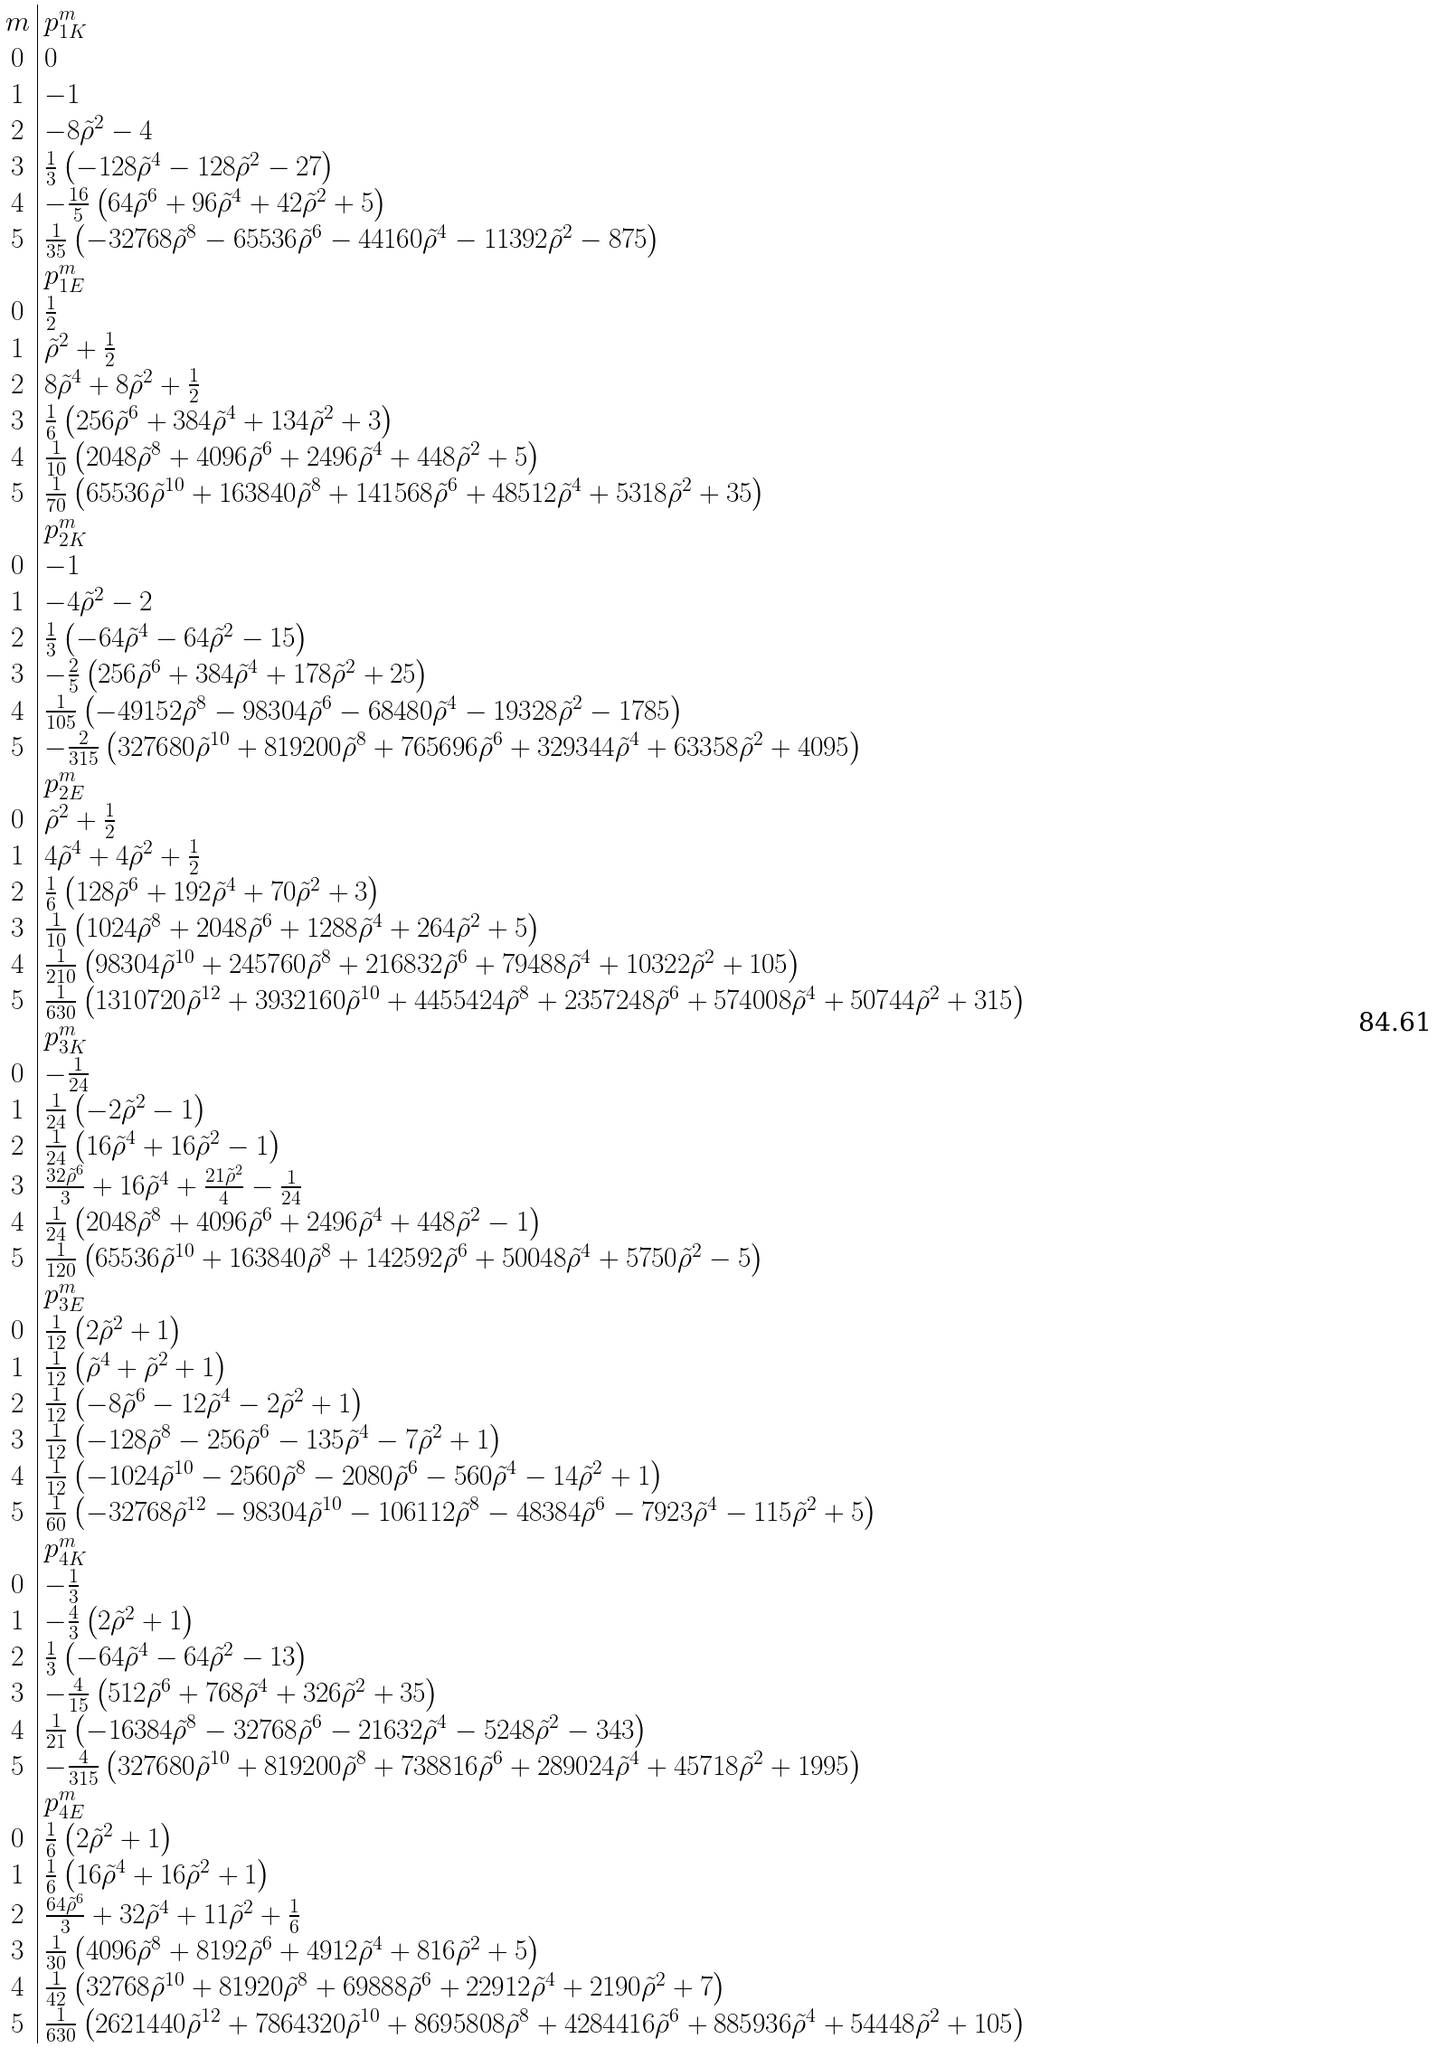<formula> <loc_0><loc_0><loc_500><loc_500>\begin{array} { c | l } m & p _ { 1 K } ^ { m } \\ 0 & 0 \\ 1 & - 1 \\ 2 & - 8 \tilde { \rho } ^ { 2 } - 4 \\ 3 & \frac { 1 } { 3 } \left ( - 1 2 8 \tilde { \rho } ^ { 4 } - 1 2 8 \tilde { \rho } ^ { 2 } - 2 7 \right ) \\ 4 & - \frac { 1 6 } { 5 } \left ( 6 4 \tilde { \rho } ^ { 6 } + 9 6 \tilde { \rho } ^ { 4 } + 4 2 \tilde { \rho } ^ { 2 } + 5 \right ) \\ 5 & \frac { 1 } { 3 5 } \left ( - 3 2 7 6 8 \tilde { \rho } ^ { 8 } - 6 5 5 3 6 \tilde { \rho } ^ { 6 } - 4 4 1 6 0 \tilde { \rho } ^ { 4 } - 1 1 3 9 2 \tilde { \rho } ^ { 2 } - 8 7 5 \right ) \\ & p _ { 1 E } ^ { m } \\ 0 & \frac { 1 } { 2 } \\ 1 & \tilde { \rho } ^ { 2 } + \frac { 1 } { 2 } \\ 2 & 8 \tilde { \rho } ^ { 4 } + 8 \tilde { \rho } ^ { 2 } + \frac { 1 } { 2 } \\ 3 & \frac { 1 } { 6 } \left ( 2 5 6 \tilde { \rho } ^ { 6 } + 3 8 4 \tilde { \rho } ^ { 4 } + 1 3 4 \tilde { \rho } ^ { 2 } + 3 \right ) \\ 4 & \frac { 1 } { 1 0 } \left ( 2 0 4 8 \tilde { \rho } ^ { 8 } + 4 0 9 6 \tilde { \rho } ^ { 6 } + 2 4 9 6 \tilde { \rho } ^ { 4 } + 4 4 8 \tilde { \rho } ^ { 2 } + 5 \right ) \\ 5 & \frac { 1 } { 7 0 } \left ( 6 5 5 3 6 \tilde { \rho } ^ { 1 0 } + 1 6 3 8 4 0 \tilde { \rho } ^ { 8 } + 1 4 1 5 6 8 \tilde { \rho } ^ { 6 } + 4 8 5 1 2 \tilde { \rho } ^ { 4 } + 5 3 1 8 \tilde { \rho } ^ { 2 } + 3 5 \right ) \\ & p _ { 2 K } ^ { m } \\ 0 & - 1 \\ 1 & - 4 \tilde { \rho } ^ { 2 } - 2 \\ 2 & \frac { 1 } { 3 } \left ( - 6 4 \tilde { \rho } ^ { 4 } - 6 4 \tilde { \rho } ^ { 2 } - 1 5 \right ) \\ 3 & - \frac { 2 } { 5 } \left ( 2 5 6 \tilde { \rho } ^ { 6 } + 3 8 4 \tilde { \rho } ^ { 4 } + 1 7 8 \tilde { \rho } ^ { 2 } + 2 5 \right ) \\ 4 & \frac { 1 } { 1 0 5 } \left ( - 4 9 1 5 2 \tilde { \rho } ^ { 8 } - 9 8 3 0 4 \tilde { \rho } ^ { 6 } - 6 8 4 8 0 \tilde { \rho } ^ { 4 } - 1 9 3 2 8 \tilde { \rho } ^ { 2 } - 1 7 8 5 \right ) \\ 5 & - \frac { 2 } { 3 1 5 } \left ( 3 2 7 6 8 0 \tilde { \rho } ^ { 1 0 } + 8 1 9 2 0 0 \tilde { \rho } ^ { 8 } + 7 6 5 6 9 6 \tilde { \rho } ^ { 6 } + 3 2 9 3 4 4 \tilde { \rho } ^ { 4 } + 6 3 3 5 8 \tilde { \rho } ^ { 2 } + 4 0 9 5 \right ) \\ & p _ { 2 E } ^ { m } \\ 0 & \tilde { \rho } ^ { 2 } + \frac { 1 } { 2 } \\ 1 & 4 \tilde { \rho } ^ { 4 } + 4 \tilde { \rho } ^ { 2 } + \frac { 1 } { 2 } \\ 2 & \frac { 1 } { 6 } \left ( 1 2 8 \tilde { \rho } ^ { 6 } + 1 9 2 \tilde { \rho } ^ { 4 } + 7 0 \tilde { \rho } ^ { 2 } + 3 \right ) \\ 3 & \frac { 1 } { 1 0 } \left ( 1 0 2 4 \tilde { \rho } ^ { 8 } + 2 0 4 8 \tilde { \rho } ^ { 6 } + 1 2 8 8 \tilde { \rho } ^ { 4 } + 2 6 4 \tilde { \rho } ^ { 2 } + 5 \right ) \\ 4 & \frac { 1 } { 2 1 0 } \left ( 9 8 3 0 4 \tilde { \rho } ^ { 1 0 } + 2 4 5 7 6 0 \tilde { \rho } ^ { 8 } + 2 1 6 8 3 2 \tilde { \rho } ^ { 6 } + 7 9 4 8 8 \tilde { \rho } ^ { 4 } + 1 0 3 2 2 \tilde { \rho } ^ { 2 } + 1 0 5 \right ) \\ 5 & \frac { 1 } { 6 3 0 } \left ( 1 3 1 0 7 2 0 \tilde { \rho } ^ { 1 2 } + 3 9 3 2 1 6 0 \tilde { \rho } ^ { 1 0 } + 4 4 5 5 4 2 4 \tilde { \rho } ^ { 8 } + 2 3 5 7 2 4 8 \tilde { \rho } ^ { 6 } + 5 7 4 0 0 8 \tilde { \rho } ^ { 4 } + 5 0 7 4 4 \tilde { \rho } ^ { 2 } + 3 1 5 \right ) \\ & p _ { 3 K } ^ { m } \\ 0 & - \frac { 1 } { 2 4 } \\ 1 & \frac { 1 } { 2 4 } \left ( - 2 \tilde { \rho } ^ { 2 } - 1 \right ) \\ 2 & \frac { 1 } { 2 4 } \left ( 1 6 \tilde { \rho } ^ { 4 } + 1 6 \tilde { \rho } ^ { 2 } - 1 \right ) \\ 3 & \frac { 3 2 \tilde { \rho } ^ { 6 } } { 3 } + 1 6 \tilde { \rho } ^ { 4 } + \frac { 2 1 \tilde { \rho } ^ { 2 } } { 4 } - \frac { 1 } { 2 4 } \\ 4 & \frac { 1 } { 2 4 } \left ( 2 0 4 8 \tilde { \rho } ^ { 8 } + 4 0 9 6 \tilde { \rho } ^ { 6 } + 2 4 9 6 \tilde { \rho } ^ { 4 } + 4 4 8 \tilde { \rho } ^ { 2 } - 1 \right ) \\ 5 & \frac { 1 } { 1 2 0 } \left ( 6 5 5 3 6 \tilde { \rho } ^ { 1 0 } + 1 6 3 8 4 0 \tilde { \rho } ^ { 8 } + 1 4 2 5 9 2 \tilde { \rho } ^ { 6 } + 5 0 0 4 8 \tilde { \rho } ^ { 4 } + 5 7 5 0 \tilde { \rho } ^ { 2 } - 5 \right ) \\ & p _ { 3 E } ^ { m } \\ 0 & \frac { 1 } { 1 2 } \left ( 2 \tilde { \rho } ^ { 2 } + 1 \right ) \\ 1 & \frac { 1 } { 1 2 } \left ( \tilde { \rho } ^ { 4 } + \tilde { \rho } ^ { 2 } + 1 \right ) \\ 2 & \frac { 1 } { 1 2 } \left ( - 8 \tilde { \rho } ^ { 6 } - 1 2 \tilde { \rho } ^ { 4 } - 2 \tilde { \rho } ^ { 2 } + 1 \right ) \\ 3 & \frac { 1 } { 1 2 } \left ( - 1 2 8 \tilde { \rho } ^ { 8 } - 2 5 6 \tilde { \rho } ^ { 6 } - 1 3 5 \tilde { \rho } ^ { 4 } - 7 \tilde { \rho } ^ { 2 } + 1 \right ) \\ 4 & \frac { 1 } { 1 2 } \left ( - 1 0 2 4 \tilde { \rho } ^ { 1 0 } - 2 5 6 0 \tilde { \rho } ^ { 8 } - 2 0 8 0 \tilde { \rho } ^ { 6 } - 5 6 0 \tilde { \rho } ^ { 4 } - 1 4 \tilde { \rho } ^ { 2 } + 1 \right ) \\ 5 & \frac { 1 } { 6 0 } \left ( - 3 2 7 6 8 \tilde { \rho } ^ { 1 2 } - 9 8 3 0 4 \tilde { \rho } ^ { 1 0 } - 1 0 6 1 1 2 \tilde { \rho } ^ { 8 } - 4 8 3 8 4 \tilde { \rho } ^ { 6 } - 7 9 2 3 \tilde { \rho } ^ { 4 } - 1 1 5 \tilde { \rho } ^ { 2 } + 5 \right ) \\ & p _ { 4 K } ^ { m } \\ 0 & - \frac { 1 } { 3 } \\ 1 & - \frac { 4 } { 3 } \left ( 2 \tilde { \rho } ^ { 2 } + 1 \right ) \\ 2 & \frac { 1 } { 3 } \left ( - 6 4 \tilde { \rho } ^ { 4 } - 6 4 \tilde { \rho } ^ { 2 } - 1 3 \right ) \\ 3 & - \frac { 4 } { 1 5 } \left ( 5 1 2 \tilde { \rho } ^ { 6 } + 7 6 8 \tilde { \rho } ^ { 4 } + 3 2 6 \tilde { \rho } ^ { 2 } + 3 5 \right ) \\ 4 & \frac { 1 } { 2 1 } \left ( - 1 6 3 8 4 \tilde { \rho } ^ { 8 } - 3 2 7 6 8 \tilde { \rho } ^ { 6 } - 2 1 6 3 2 \tilde { \rho } ^ { 4 } - 5 2 4 8 \tilde { \rho } ^ { 2 } - 3 4 3 \right ) \\ 5 & - \frac { 4 } { 3 1 5 } \left ( 3 2 7 6 8 0 \tilde { \rho } ^ { 1 0 } + 8 1 9 2 0 0 \tilde { \rho } ^ { 8 } + 7 3 8 8 1 6 \tilde { \rho } ^ { 6 } + 2 8 9 0 2 4 \tilde { \rho } ^ { 4 } + 4 5 7 1 8 \tilde { \rho } ^ { 2 } + 1 9 9 5 \right ) \\ & p _ { 4 E } ^ { m } \\ 0 & \frac { 1 } { 6 } \left ( 2 \tilde { \rho } ^ { 2 } + 1 \right ) \\ 1 & \frac { 1 } { 6 } \left ( 1 6 \tilde { \rho } ^ { 4 } + 1 6 \tilde { \rho } ^ { 2 } + 1 \right ) \\ 2 & \frac { 6 4 \tilde { \rho } ^ { 6 } } { 3 } + 3 2 \tilde { \rho } ^ { 4 } + 1 1 \tilde { \rho } ^ { 2 } + \frac { 1 } { 6 } \\ 3 & \frac { 1 } { 3 0 } \left ( 4 0 9 6 \tilde { \rho } ^ { 8 } + 8 1 9 2 \tilde { \rho } ^ { 6 } + 4 9 1 2 \tilde { \rho } ^ { 4 } + 8 1 6 \tilde { \rho } ^ { 2 } + 5 \right ) \\ 4 & \frac { 1 } { 4 2 } \left ( 3 2 7 6 8 \tilde { \rho } ^ { 1 0 } + 8 1 9 2 0 \tilde { \rho } ^ { 8 } + 6 9 8 8 8 \tilde { \rho } ^ { 6 } + 2 2 9 1 2 \tilde { \rho } ^ { 4 } + 2 1 9 0 \tilde { \rho } ^ { 2 } + 7 \right ) \\ 5 & \frac { 1 } { 6 3 0 } \left ( 2 6 2 1 4 4 0 \tilde { \rho } ^ { 1 2 } + 7 8 6 4 3 2 0 \tilde { \rho } ^ { 1 0 } + 8 6 9 5 8 0 8 \tilde { \rho } ^ { 8 } + 4 2 8 4 4 1 6 \tilde { \rho } ^ { 6 } + 8 8 5 9 3 6 \tilde { \rho } ^ { 4 } + 5 4 4 4 8 \tilde { \rho } ^ { 2 } + 1 0 5 \right ) \\ \end{array}</formula> 